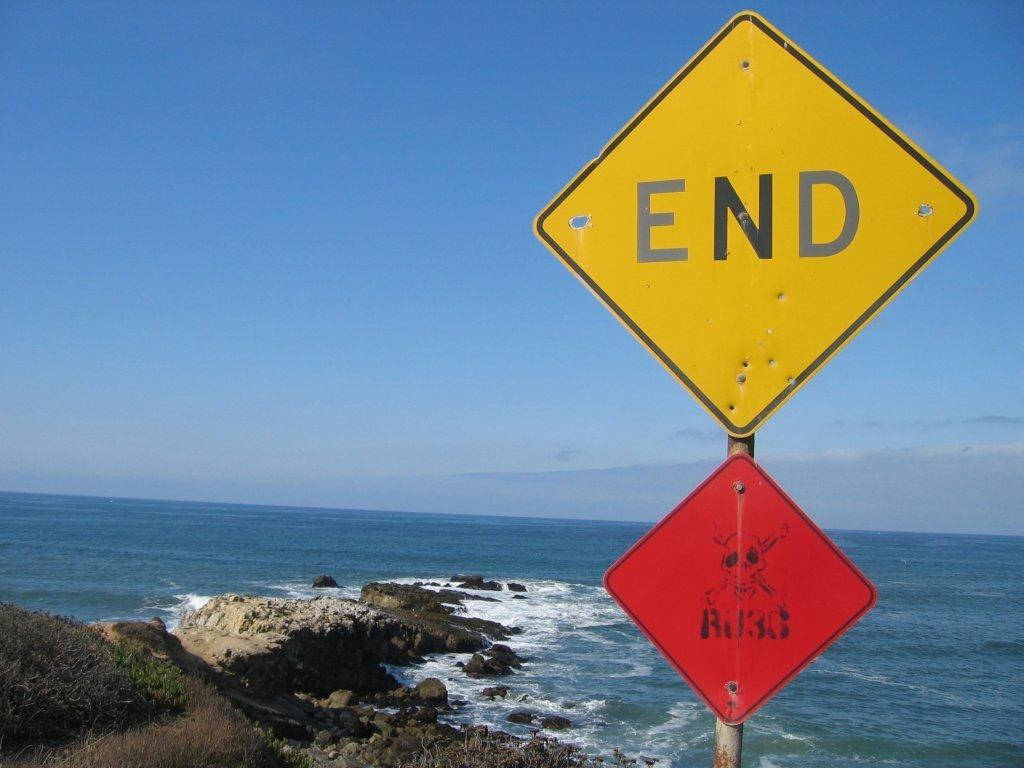<image>
Relay a brief, clear account of the picture shown. A picture of a beach with a sign that says End. 